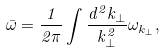<formula> <loc_0><loc_0><loc_500><loc_500>\bar { \omega } = \frac { 1 } { 2 \pi } \int \frac { d ^ { 2 } k _ { \bot } } { k _ { \bot } ^ { 2 } } \omega _ { k _ { \bot } } ,</formula> 